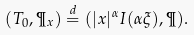Convert formula to latex. <formula><loc_0><loc_0><loc_500><loc_500>( T _ { 0 } , \P _ { x } ) \stackrel { d } { = } ( | x | ^ { \alpha } I ( \alpha \xi ) , \P ) .</formula> 